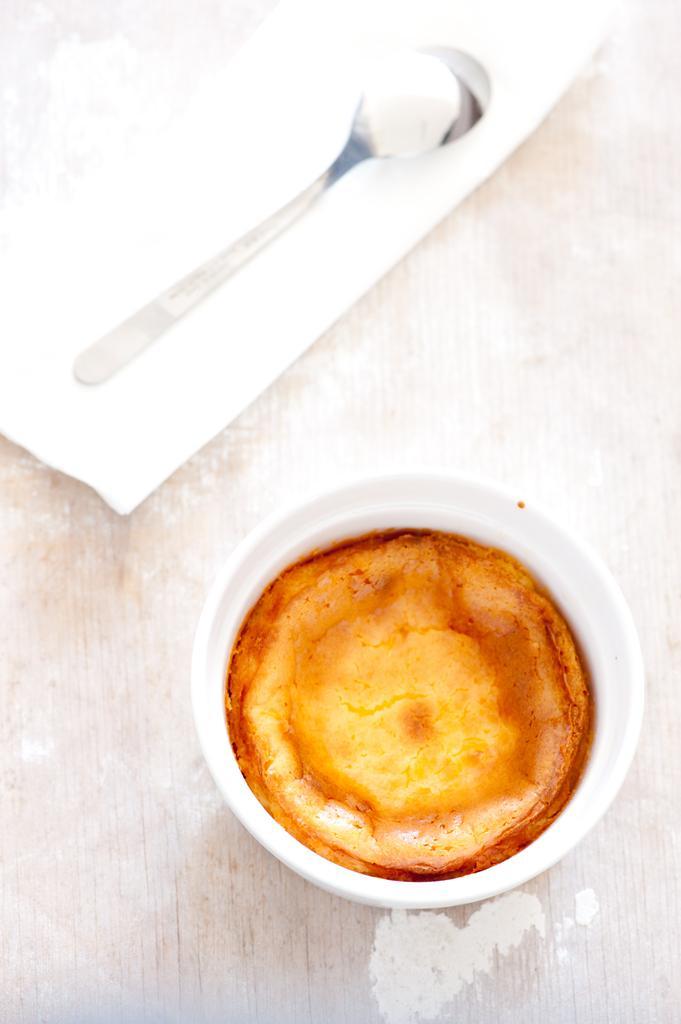Describe this image in one or two sentences. In the foreground I can see beverage in a cup, paper and a spoon may be kept on the table. This image is taken may be in a room. 